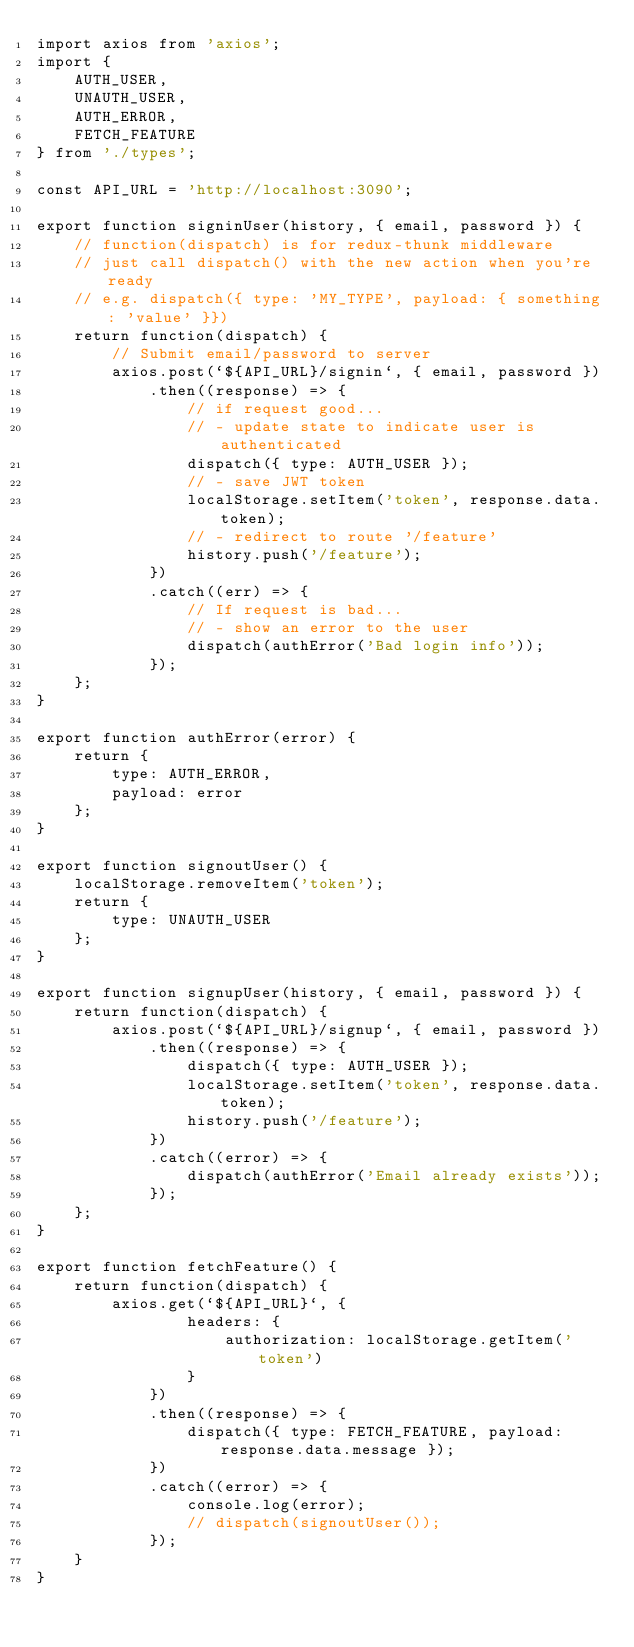<code> <loc_0><loc_0><loc_500><loc_500><_JavaScript_>import axios from 'axios';
import { 
    AUTH_USER, 
    UNAUTH_USER, 
    AUTH_ERROR,
    FETCH_FEATURE
} from './types';

const API_URL = 'http://localhost:3090';

export function signinUser(history, { email, password }) {
    // function(dispatch) is for redux-thunk middleware
    // just call dispatch() with the new action when you're ready
    // e.g. dispatch({ type: 'MY_TYPE', payload: { something: 'value' }})
    return function(dispatch) {
        // Submit email/password to server
        axios.post(`${API_URL}/signin`, { email, password })
            .then((response) => {
                // if request good...
                // - update state to indicate user is authenticated
                dispatch({ type: AUTH_USER });
                // - save JWT token
                localStorage.setItem('token', response.data.token);
                // - redirect to route '/feature'
                history.push('/feature');
            })
            .catch((err) => {
                // If request is bad...
                // - show an error to the user
                dispatch(authError('Bad login info'));
            });
    };
}

export function authError(error) {
    return {
        type: AUTH_ERROR,
        payload: error
    };
}

export function signoutUser() {
    localStorage.removeItem('token');
    return {
        type: UNAUTH_USER
    };
}

export function signupUser(history, { email, password }) {
    return function(dispatch) {
        axios.post(`${API_URL}/signup`, { email, password })
            .then((response) => {
                dispatch({ type: AUTH_USER });
                localStorage.setItem('token', response.data.token);
                history.push('/feature');
            })
            .catch((error) => {
                dispatch(authError('Email already exists'));                
            });
    };
}

export function fetchFeature() {
    return function(dispatch) {
        axios.get(`${API_URL}`, {
                headers: {
                    authorization: localStorage.getItem('token')
                }
            })
            .then((response) => {
                dispatch({ type: FETCH_FEATURE, payload: response.data.message });
            })
            .catch((error) => {
                console.log(error);
                // dispatch(signoutUser());
            });
    }
}</code> 